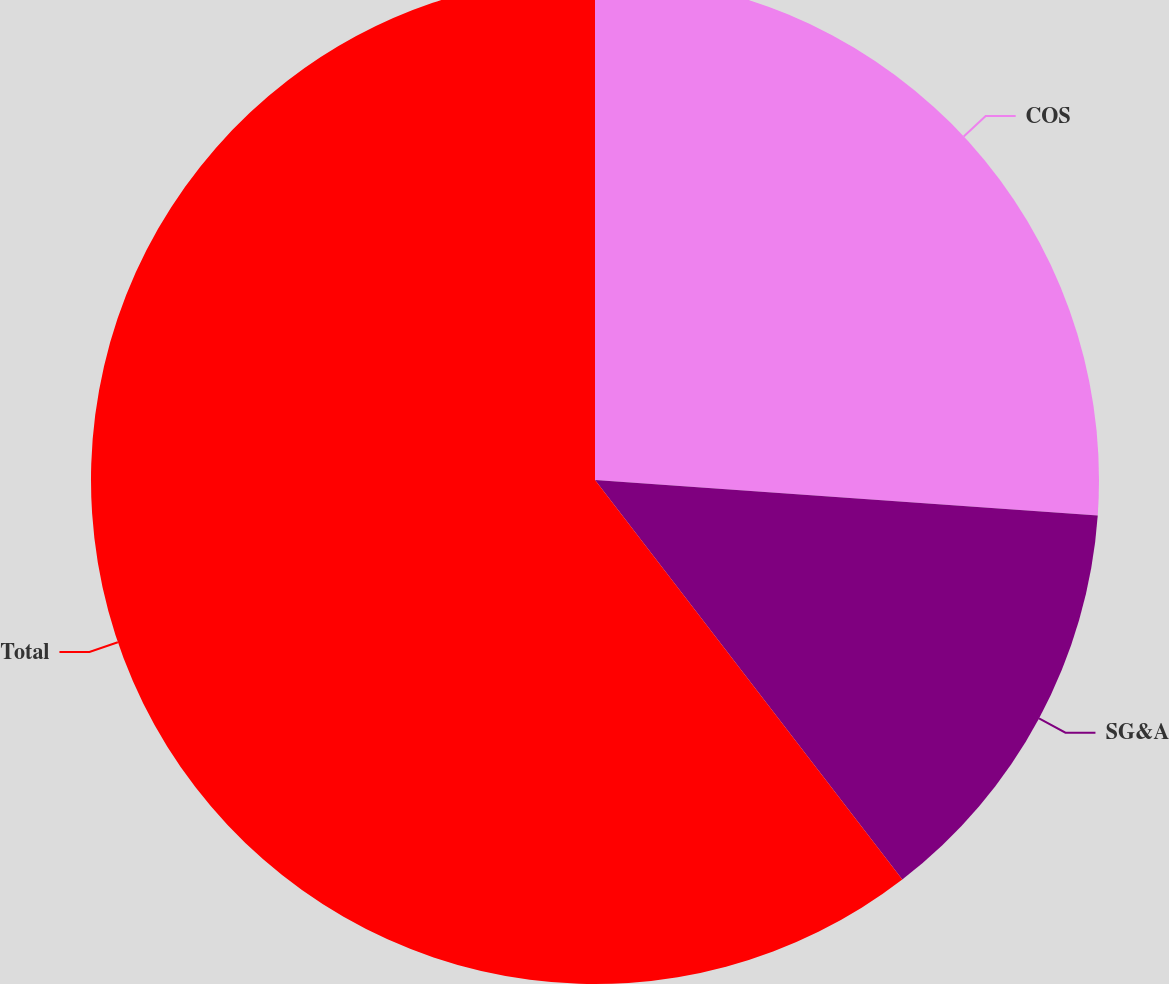<chart> <loc_0><loc_0><loc_500><loc_500><pie_chart><fcel>COS<fcel>SG&A<fcel>Total<nl><fcel>26.12%<fcel>13.44%<fcel>60.43%<nl></chart> 